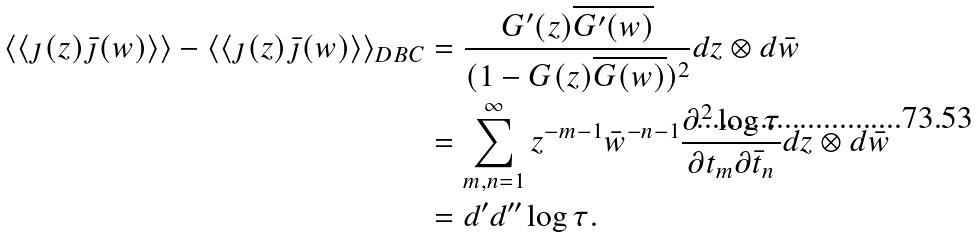<formula> <loc_0><loc_0><loc_500><loc_500>\langle \langle \jmath ( z ) \bar { \jmath } ( w ) \rangle \rangle - \langle \langle \jmath ( z ) \bar { \jmath } ( w ) \rangle \rangle _ { D B C } & = \frac { G ^ { \prime } ( z ) \overline { G ^ { \prime } ( w ) } } { ( 1 - G ( z ) \overline { G ( w ) } ) ^ { 2 } } d z \otimes d \bar { w } \\ & = \sum _ { m , n = 1 } ^ { \infty } z ^ { - m - 1 } \bar { w } ^ { - n - 1 } \frac { \partial ^ { 2 } \log \tau } { \partial t _ { m } \partial \bar { t } _ { n } } d z \otimes d \bar { w } \\ & = d ^ { \prime } d ^ { \prime \prime } \log \tau .</formula> 